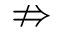<formula> <loc_0><loc_0><loc_500><loc_500>\ n R i g h t a r r o w</formula> 